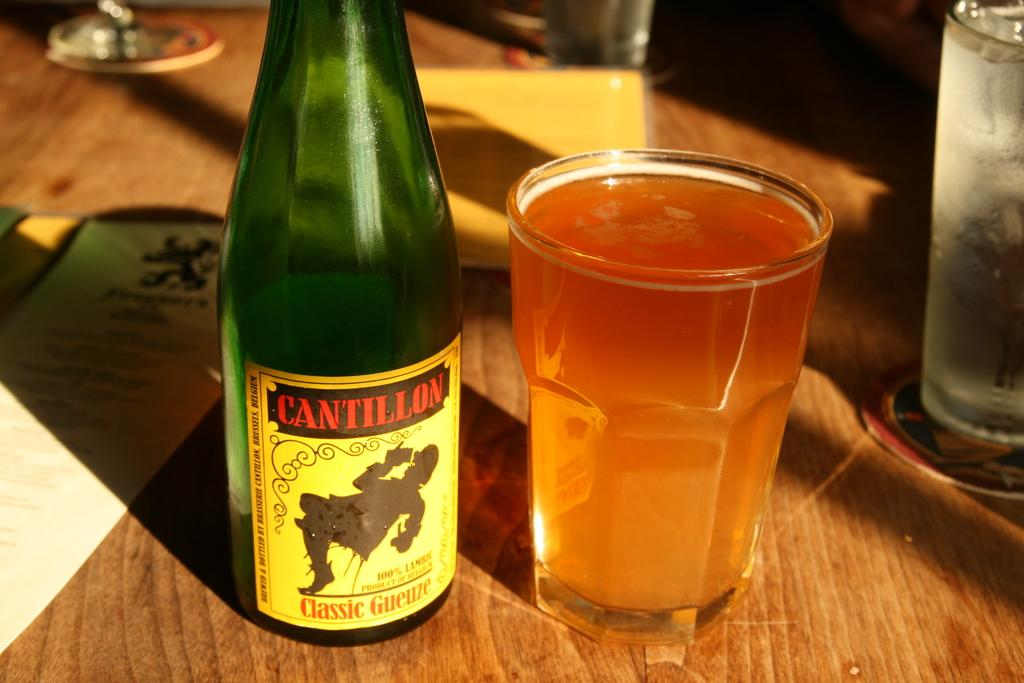<image>
Present a compact description of the photo's key features. A bottle of Cantillon has been poured into a glass 